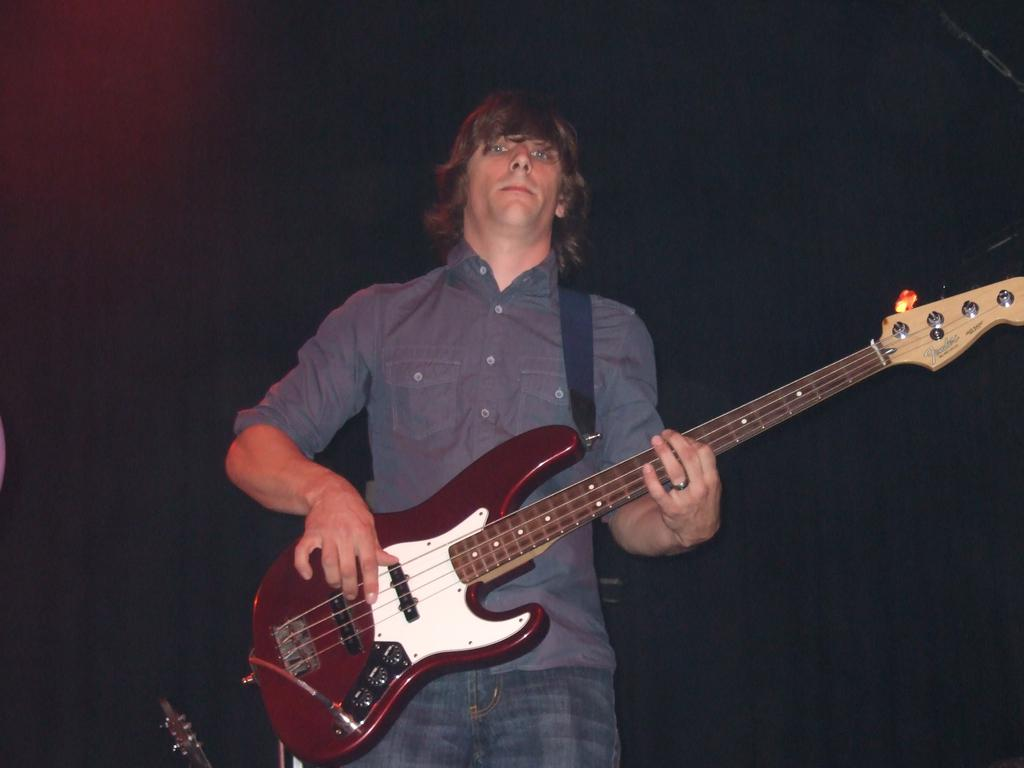What is the main subject of the image? The main subject of the image is a man. What is the man holding in his hand? The man is holding a guitar in his hand. What type of nation is depicted in the image? There is no nation depicted in the image; it features a man holding a guitar. Where is the drawer located in the image? There is no drawer present in the image. 